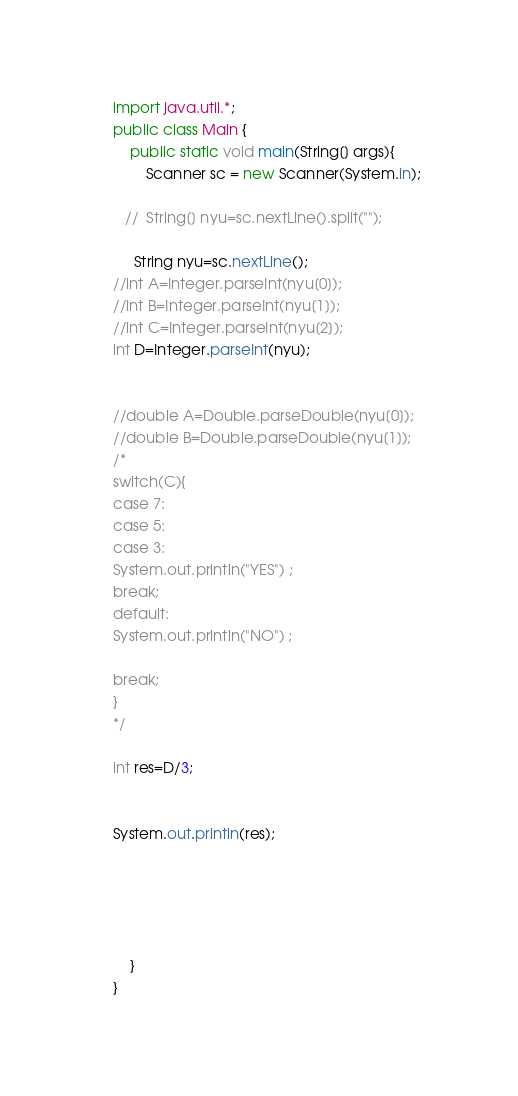Convert code to text. <code><loc_0><loc_0><loc_500><loc_500><_Java_>
import java.util.*;
public class Main {
	public static void main(String[] args){
		Scanner sc = new Scanner(System.in);
 
   //  String[] nyu=sc.nextLine().split("");

     String nyu=sc.nextLine();
//int A=Integer.parseInt(nyu[0]);
//int B=Integer.parseInt(nyu[1]);
//int C=Integer.parseInt(nyu[2]);
int D=Integer.parseInt(nyu);


//double A=Double.parseDouble(nyu[0]);
//double B=Double.parseDouble(nyu[1]);
/*
switch(C){
case 7:
case 5:
case 3:
System.out.println("YES") ;
break;
default:
System.out.println("NO") ;

break;
}
*/

int res=D/3;


System.out.println(res);





	}
}</code> 